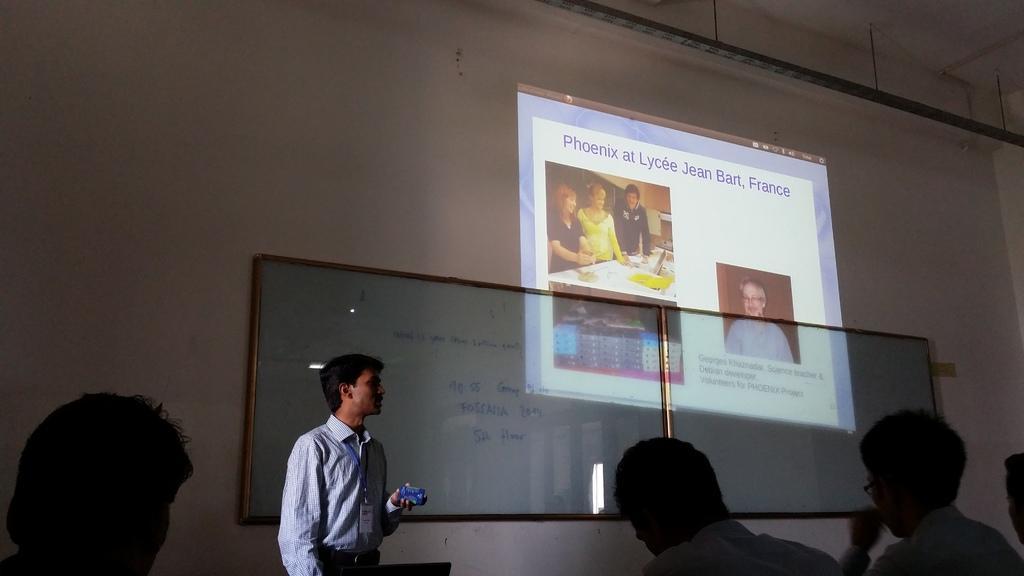Please provide a concise description of this image. At the bottom of the image few people are sitting. In front of them a person is standing and holding something in his hand. Behind him there is a wall, on the wall there is a board and screen. At the top of the image there is ceiling. 